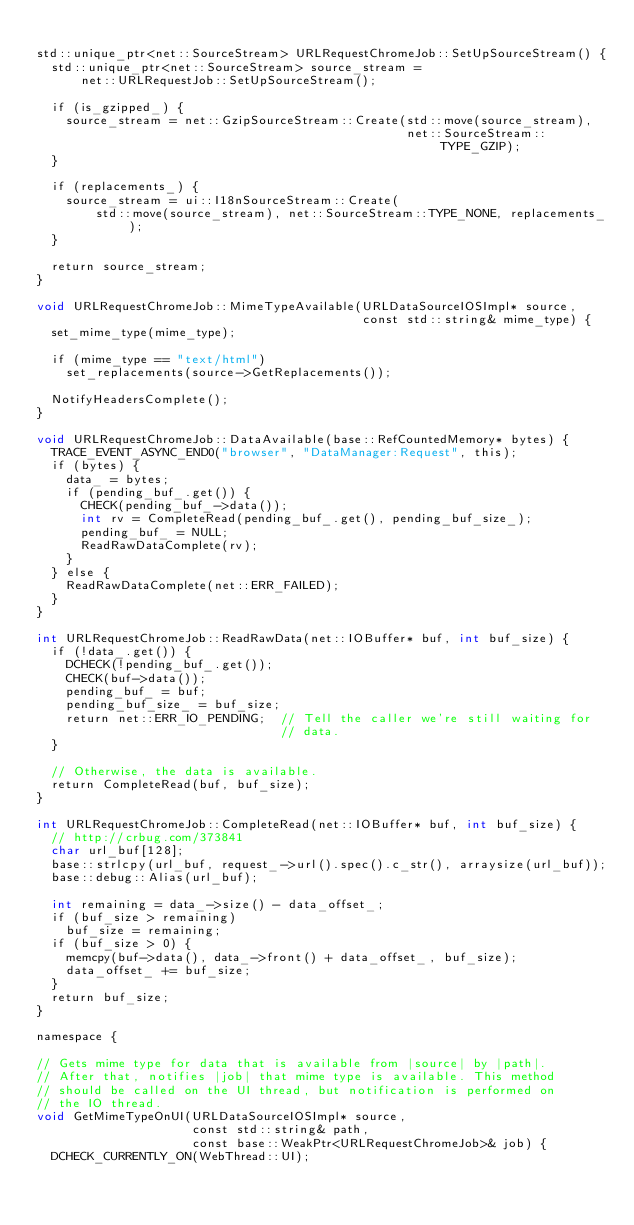Convert code to text. <code><loc_0><loc_0><loc_500><loc_500><_ObjectiveC_>
std::unique_ptr<net::SourceStream> URLRequestChromeJob::SetUpSourceStream() {
  std::unique_ptr<net::SourceStream> source_stream =
      net::URLRequestJob::SetUpSourceStream();

  if (is_gzipped_) {
    source_stream = net::GzipSourceStream::Create(std::move(source_stream),
                                                  net::SourceStream::TYPE_GZIP);
  }

  if (replacements_) {
    source_stream = ui::I18nSourceStream::Create(
        std::move(source_stream), net::SourceStream::TYPE_NONE, replacements_);
  }

  return source_stream;
}

void URLRequestChromeJob::MimeTypeAvailable(URLDataSourceIOSImpl* source,
                                            const std::string& mime_type) {
  set_mime_type(mime_type);

  if (mime_type == "text/html")
    set_replacements(source->GetReplacements());

  NotifyHeadersComplete();
}

void URLRequestChromeJob::DataAvailable(base::RefCountedMemory* bytes) {
  TRACE_EVENT_ASYNC_END0("browser", "DataManager:Request", this);
  if (bytes) {
    data_ = bytes;
    if (pending_buf_.get()) {
      CHECK(pending_buf_->data());
      int rv = CompleteRead(pending_buf_.get(), pending_buf_size_);
      pending_buf_ = NULL;
      ReadRawDataComplete(rv);
    }
  } else {
    ReadRawDataComplete(net::ERR_FAILED);
  }
}

int URLRequestChromeJob::ReadRawData(net::IOBuffer* buf, int buf_size) {
  if (!data_.get()) {
    DCHECK(!pending_buf_.get());
    CHECK(buf->data());
    pending_buf_ = buf;
    pending_buf_size_ = buf_size;
    return net::ERR_IO_PENDING;  // Tell the caller we're still waiting for
                                 // data.
  }

  // Otherwise, the data is available.
  return CompleteRead(buf, buf_size);
}

int URLRequestChromeJob::CompleteRead(net::IOBuffer* buf, int buf_size) {
  // http://crbug.com/373841
  char url_buf[128];
  base::strlcpy(url_buf, request_->url().spec().c_str(), arraysize(url_buf));
  base::debug::Alias(url_buf);

  int remaining = data_->size() - data_offset_;
  if (buf_size > remaining)
    buf_size = remaining;
  if (buf_size > 0) {
    memcpy(buf->data(), data_->front() + data_offset_, buf_size);
    data_offset_ += buf_size;
  }
  return buf_size;
}

namespace {

// Gets mime type for data that is available from |source| by |path|.
// After that, notifies |job| that mime type is available. This method
// should be called on the UI thread, but notification is performed on
// the IO thread.
void GetMimeTypeOnUI(URLDataSourceIOSImpl* source,
                     const std::string& path,
                     const base::WeakPtr<URLRequestChromeJob>& job) {
  DCHECK_CURRENTLY_ON(WebThread::UI);</code> 